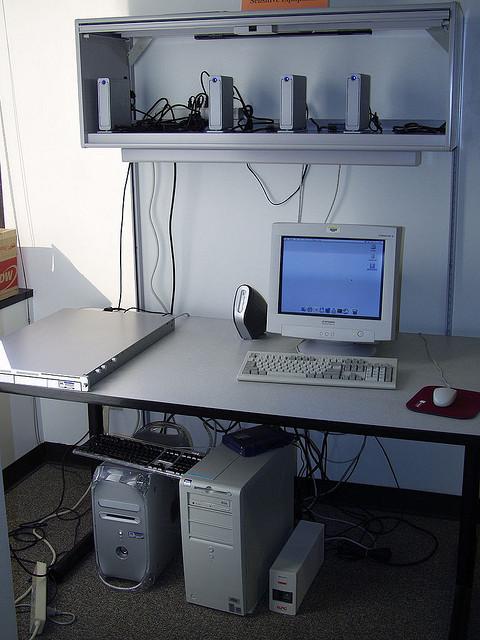Is the computer on or off?
Keep it brief. On. Which room is this?
Quick response, please. Office. How many monitors are there?
Quick response, please. 1. What color is the mouse?
Answer briefly. White. Is there a printer?
Concise answer only. No. Where is the printer?
Give a very brief answer. Under desk. What color is the desk?
Keep it brief. White. Is this a kitchen?
Short answer required. No. Is this a laptop?
Short answer required. No. 